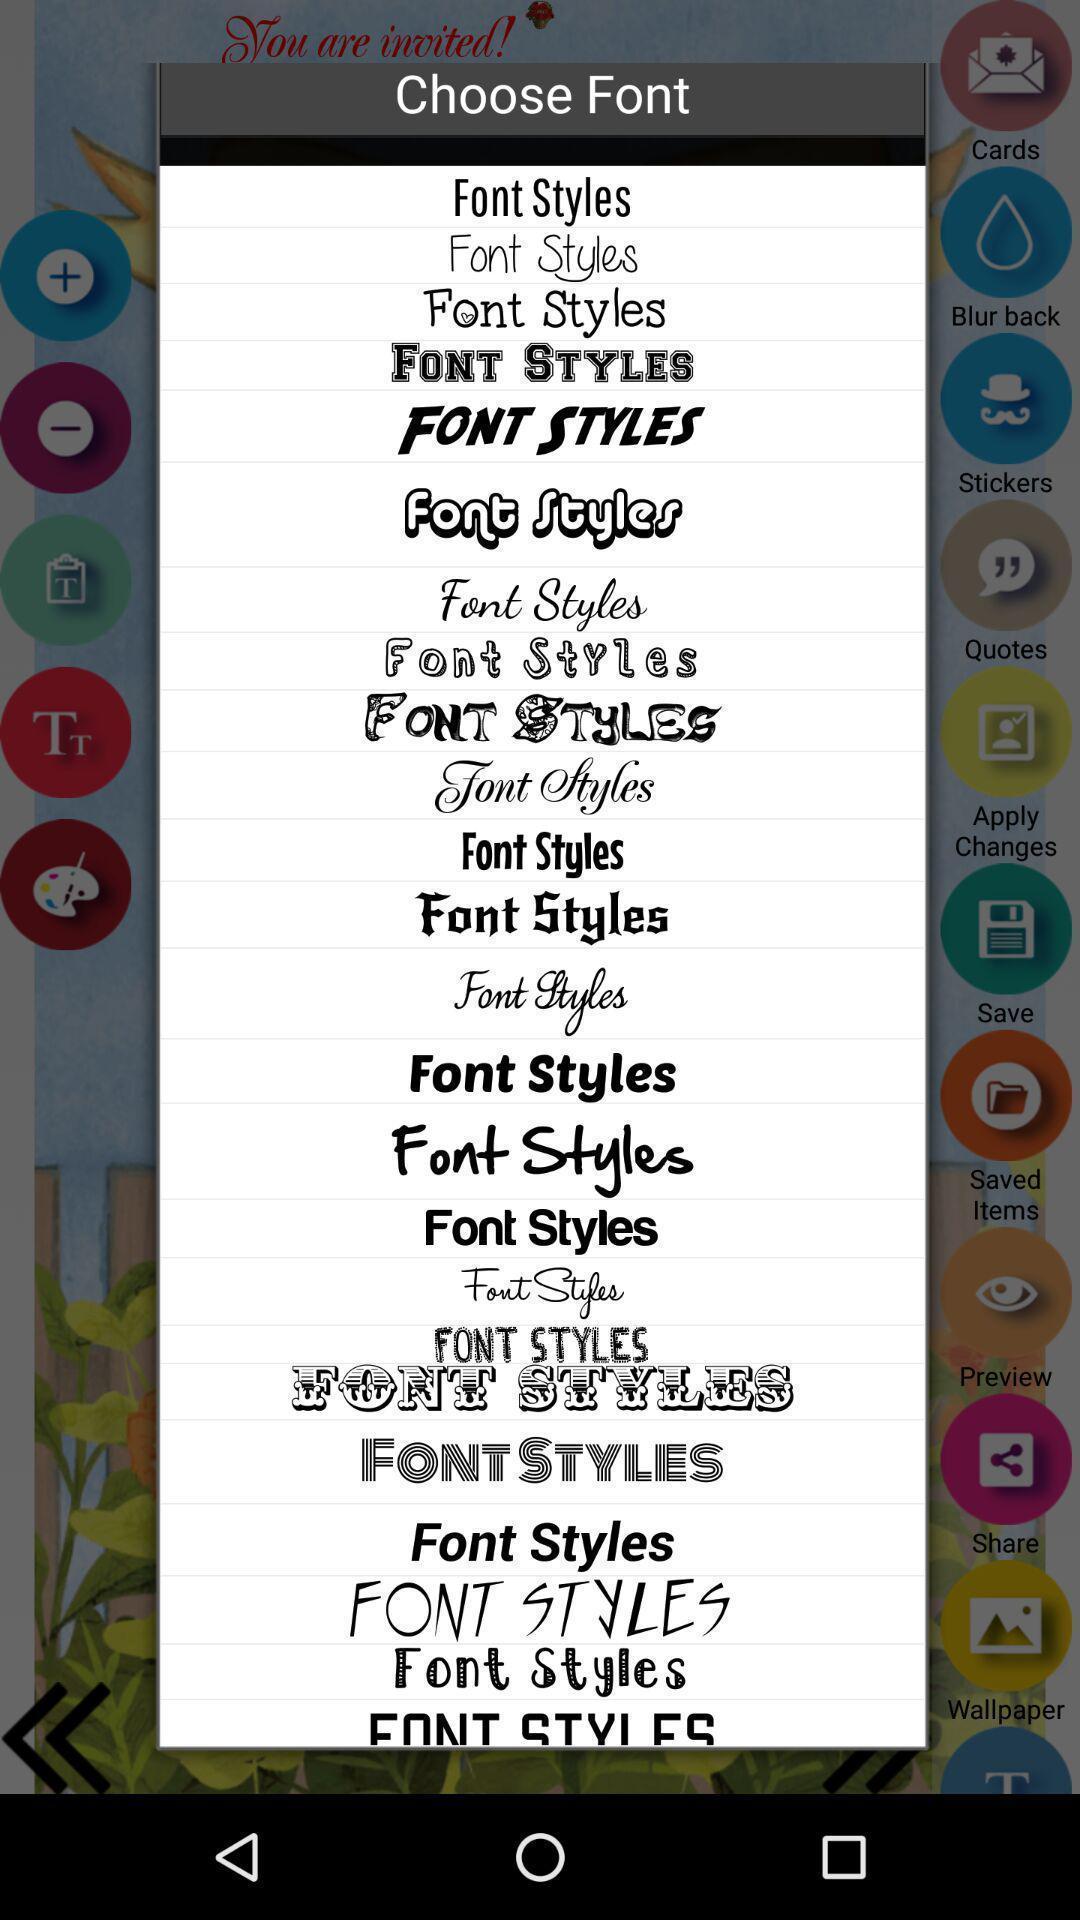Give me a summary of this screen capture. Screen shows list of fonts in invitation cards app. 